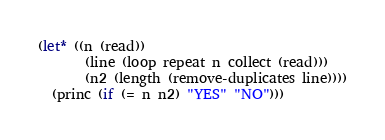Convert code to text. <code><loc_0><loc_0><loc_500><loc_500><_Lisp_>(let* ((n (read))
       (line (loop repeat n collect (read)))
       (n2 (length (remove-duplicates line))))
  (princ (if (= n n2) "YES" "NO")))
</code> 